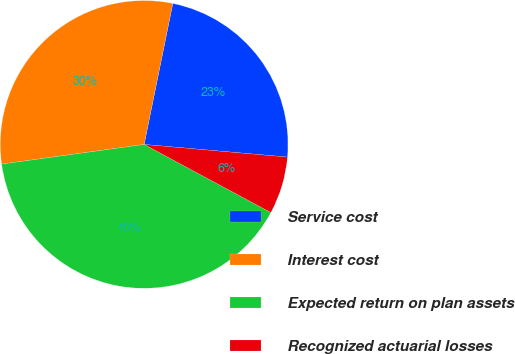<chart> <loc_0><loc_0><loc_500><loc_500><pie_chart><fcel>Service cost<fcel>Interest cost<fcel>Expected return on plan assets<fcel>Recognized actuarial losses<nl><fcel>23.21%<fcel>30.38%<fcel>39.97%<fcel>6.45%<nl></chart> 